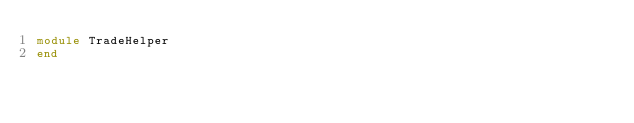<code> <loc_0><loc_0><loc_500><loc_500><_Ruby_>module TradeHelper
end
</code> 